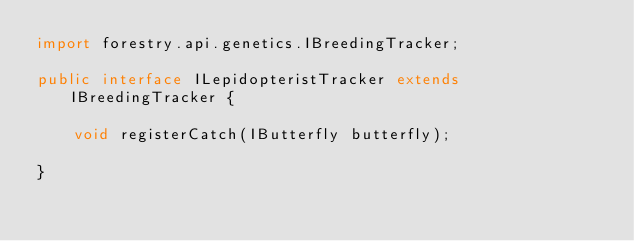<code> <loc_0><loc_0><loc_500><loc_500><_Java_>import forestry.api.genetics.IBreedingTracker;

public interface ILepidopteristTracker extends IBreedingTracker {

	void registerCatch(IButterfly butterfly);
	
}
</code> 